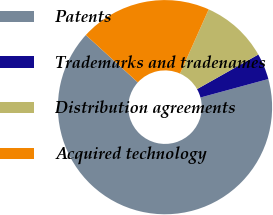Convert chart to OTSL. <chart><loc_0><loc_0><loc_500><loc_500><pie_chart><fcel>Patents<fcel>Trademarks and tradenames<fcel>Distribution agreements<fcel>Acquired technology<nl><fcel>65.99%<fcel>3.94%<fcel>10.14%<fcel>19.93%<nl></chart> 